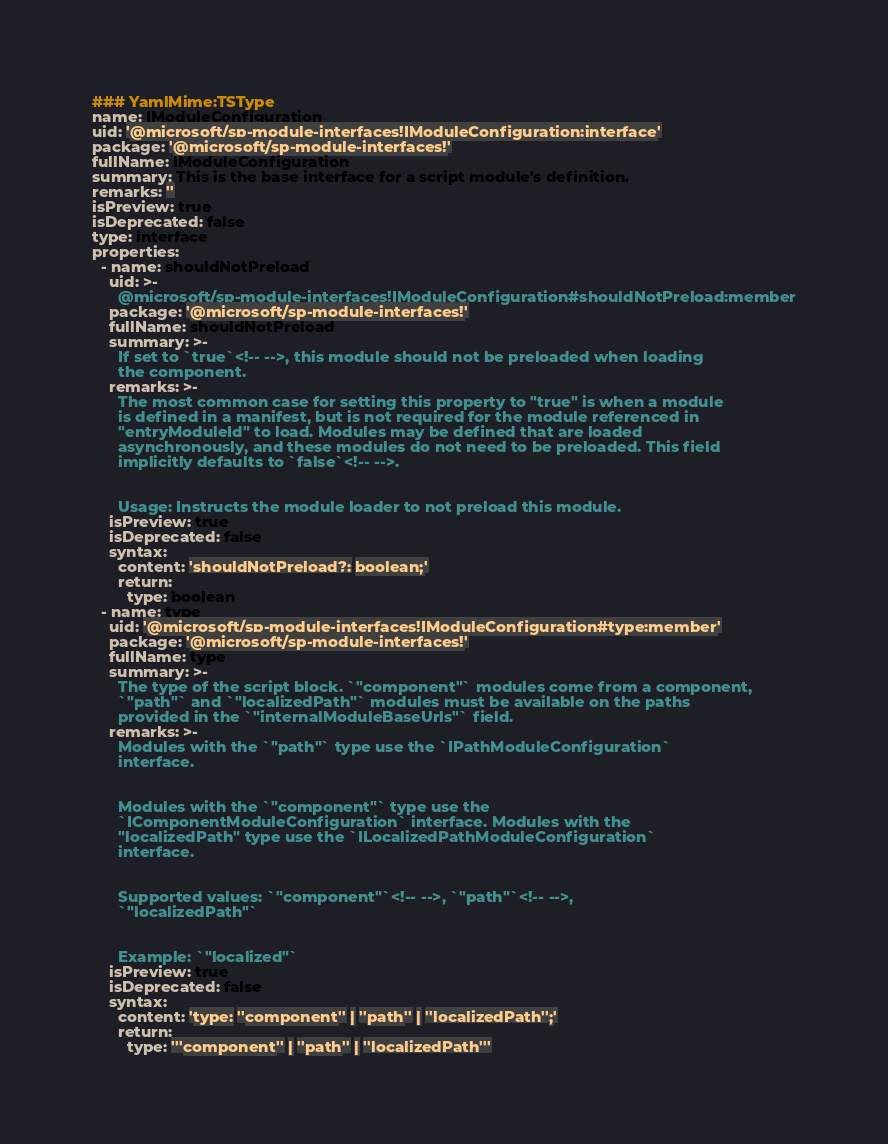<code> <loc_0><loc_0><loc_500><loc_500><_YAML_>### YamlMime:TSType
name: IModuleConfiguration
uid: '@microsoft/sp-module-interfaces!IModuleConfiguration:interface'
package: '@microsoft/sp-module-interfaces!'
fullName: IModuleConfiguration
summary: This is the base interface for a script module's definition.
remarks: ''
isPreview: true
isDeprecated: false
type: interface
properties:
  - name: shouldNotPreload
    uid: >-
      @microsoft/sp-module-interfaces!IModuleConfiguration#shouldNotPreload:member
    package: '@microsoft/sp-module-interfaces!'
    fullName: shouldNotPreload
    summary: >-
      If set to `true`<!-- -->, this module should not be preloaded when loading
      the component.
    remarks: >-
      The most common case for setting this property to "true" is when a module
      is defined in a manifest, but is not required for the module referenced in
      "entryModuleId" to load. Modules may be defined that are loaded
      asynchronously, and these modules do not need to be preloaded. This field
      implicitly defaults to `false`<!-- -->.


      Usage: Instructs the module loader to not preload this module.
    isPreview: true
    isDeprecated: false
    syntax:
      content: 'shouldNotPreload?: boolean;'
      return:
        type: boolean
  - name: type
    uid: '@microsoft/sp-module-interfaces!IModuleConfiguration#type:member'
    package: '@microsoft/sp-module-interfaces!'
    fullName: type
    summary: >-
      The type of the script block. `"component"` modules come from a component,
      `"path"` and `"localizedPath"` modules must be available on the paths
      provided in the `"internalModuleBaseUrls"` field.
    remarks: >-
      Modules with the `"path"` type use the `IPathModuleConfiguration`
      interface.


      Modules with the `"component"` type use the
      `IComponentModuleConfiguration` interface. Modules with the
      "localizedPath" type use the `ILocalizedPathModuleConfiguration`
      interface.


      Supported values: `"component"`<!-- -->, `"path"`<!-- -->,
      `"localizedPath"`


      Example: `"localized"`
    isPreview: true
    isDeprecated: false
    syntax:
      content: 'type: ''component'' | ''path'' | ''localizedPath'';'
      return:
        type: '''component'' | ''path'' | ''localizedPath'''
</code> 